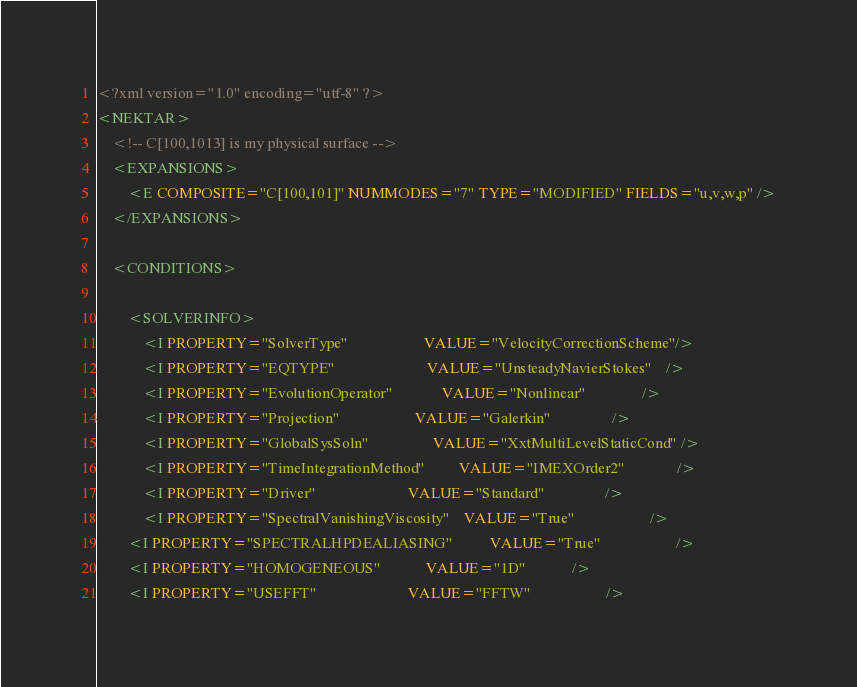Convert code to text. <code><loc_0><loc_0><loc_500><loc_500><_XML_><?xml version="1.0" encoding="utf-8" ?>
<NEKTAR>
	<!-- C[100,1013] is my physical surface -->
	<EXPANSIONS>
        <E COMPOSITE="C[100,101]" NUMMODES="7" TYPE="MODIFIED" FIELDS="u,v,w,p" />
    </EXPANSIONS>

    <CONDITIONS>
    
    	<SOLVERINFO>
            <I PROPERTY="SolverType"                    VALUE="VelocityCorrectionScheme"/>
            <I PROPERTY="EQTYPE"                        VALUE="UnsteadyNavierStokes"    />
            <I PROPERTY="EvolutionOperator"             VALUE="Nonlinear"               />
            <I PROPERTY="Projection"                    VALUE="Galerkin"                />
            <I PROPERTY="GlobalSysSoln"                 VALUE="XxtMultiLevelStaticCond" />
            <I PROPERTY="TimeIntegrationMethod"         VALUE="IMEXOrder2"              />
            <I PROPERTY="Driver"                        VALUE="Standard"                />
            <I PROPERTY="SpectralVanishingViscosity"    VALUE="True"                    />
	    <I PROPERTY="SPECTRALHPDEALIASING"          VALUE="True"                    />
	    <I PROPERTY="HOMOGENEOUS"			VALUE="1D"			/>
	    <I PROPERTY="USEFFT"                        VALUE="FFTW"                    /></code> 